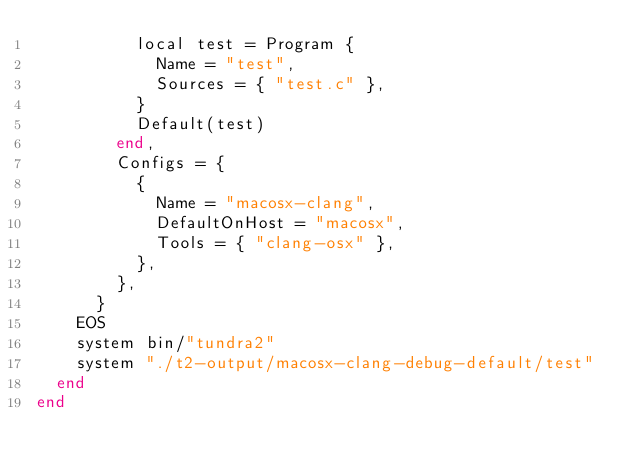Convert code to text. <code><loc_0><loc_0><loc_500><loc_500><_Ruby_>          local test = Program {
            Name = "test",
            Sources = { "test.c" },
          }
          Default(test)
        end,
        Configs = {
          {
            Name = "macosx-clang",
            DefaultOnHost = "macosx",
            Tools = { "clang-osx" },
          },
        },
      }
    EOS
    system bin/"tundra2"
    system "./t2-output/macosx-clang-debug-default/test"
  end
end
</code> 